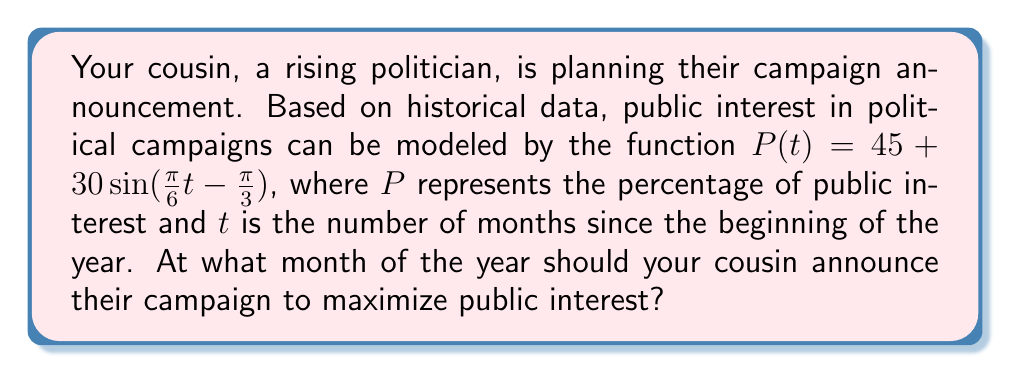Provide a solution to this math problem. To solve this problem, we need to find the maximum value of the sinusoidal function:

1) The general form of a sinusoidal function is:
   $f(t) = A\sin(Bt - C) + D$
   Where:
   $A$ is the amplitude
   $B$ is the angular frequency
   $C$ is the phase shift
   $D$ is the vertical shift

2) In our function $P(t) = 45 + 30\sin(\frac{\pi}{6}t - \frac{\pi}{3})$:
   $A = 30$
   $B = \frac{\pi}{6}$
   $C = \frac{\pi}{3}$
   $D = 45$

3) The maximum value of a sine function occurs when the argument of sine equals $\frac{\pi}{2}$ (or 90°). So:

   $\frac{\pi}{6}t - \frac{\pi}{3} = \frac{\pi}{2}$

4) Solve for $t$:
   $\frac{\pi}{6}t = \frac{\pi}{2} + \frac{\pi}{3} = \frac{5\pi}{6}$
   $t = \frac{5\pi}{6} \cdot \frac{6}{\pi} = 5$

5) Since $t$ represents months since the beginning of the year, $t = 5$ corresponds to May.

6) To verify this is a maximum, not a minimum, we can check the second derivative or simply note that $A$ is positive, so this will be a maximum.

Therefore, your cousin should announce their campaign in May to maximize public interest.
Answer: May (5 months after the beginning of the year) 